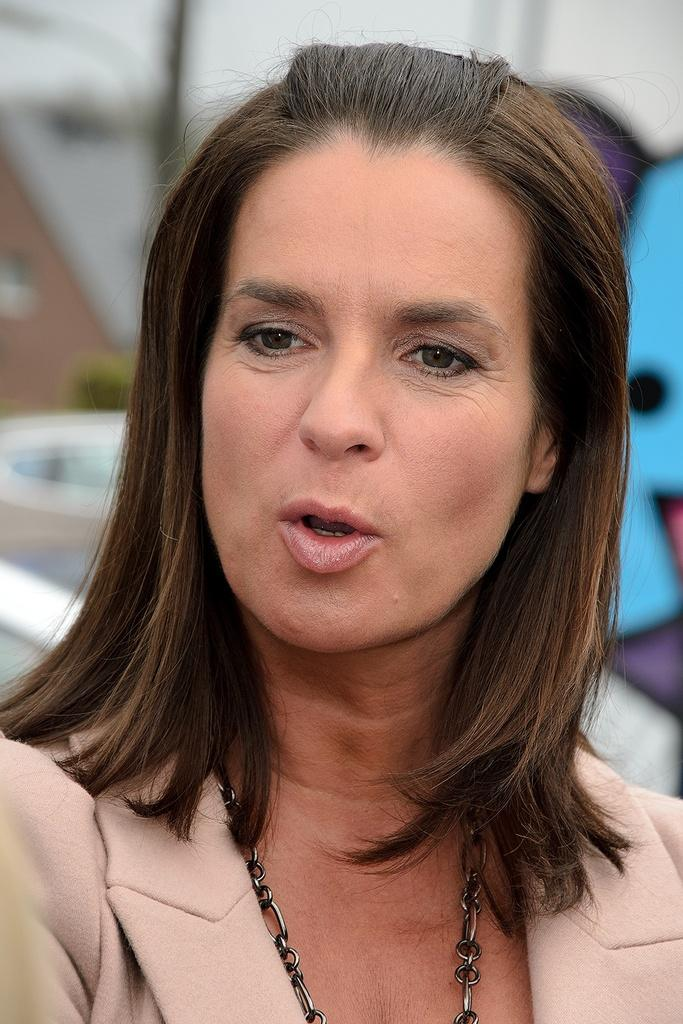Who is the main subject in the image? There is a woman in the image. What accessory is the woman wearing? The woman is wearing a necklace. Can you describe the background of the image? The background of the image is blurred. How does the woman slip on the ice in the image? There is no ice present in the image, and the woman is not shown slipping. 